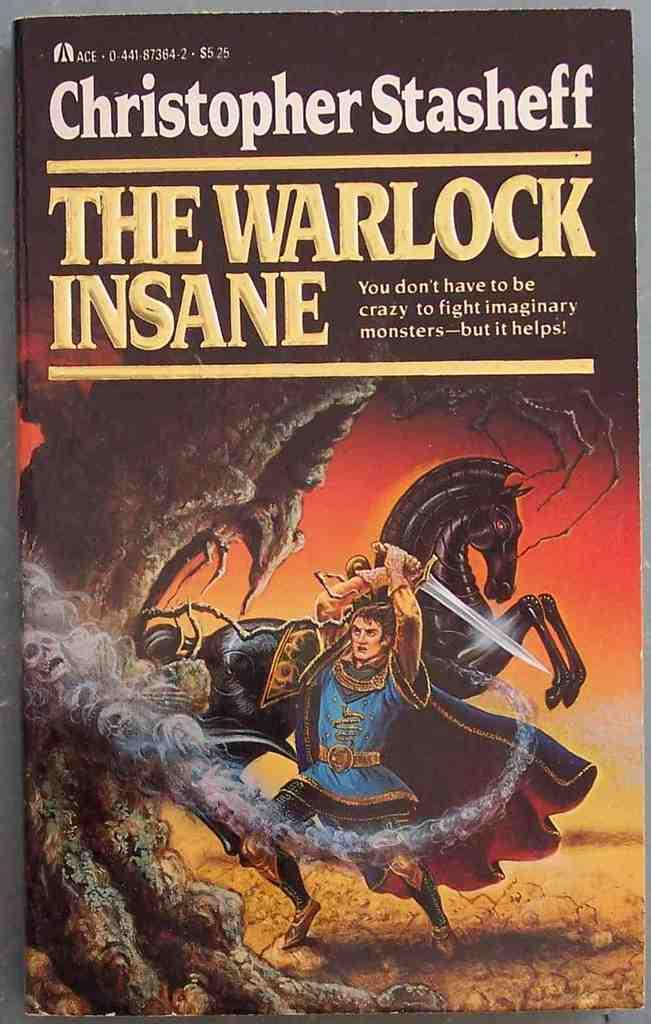<image>
Relay a brief, clear account of the picture shown. A man with a sword is on the cover of The Warlock Insane. 